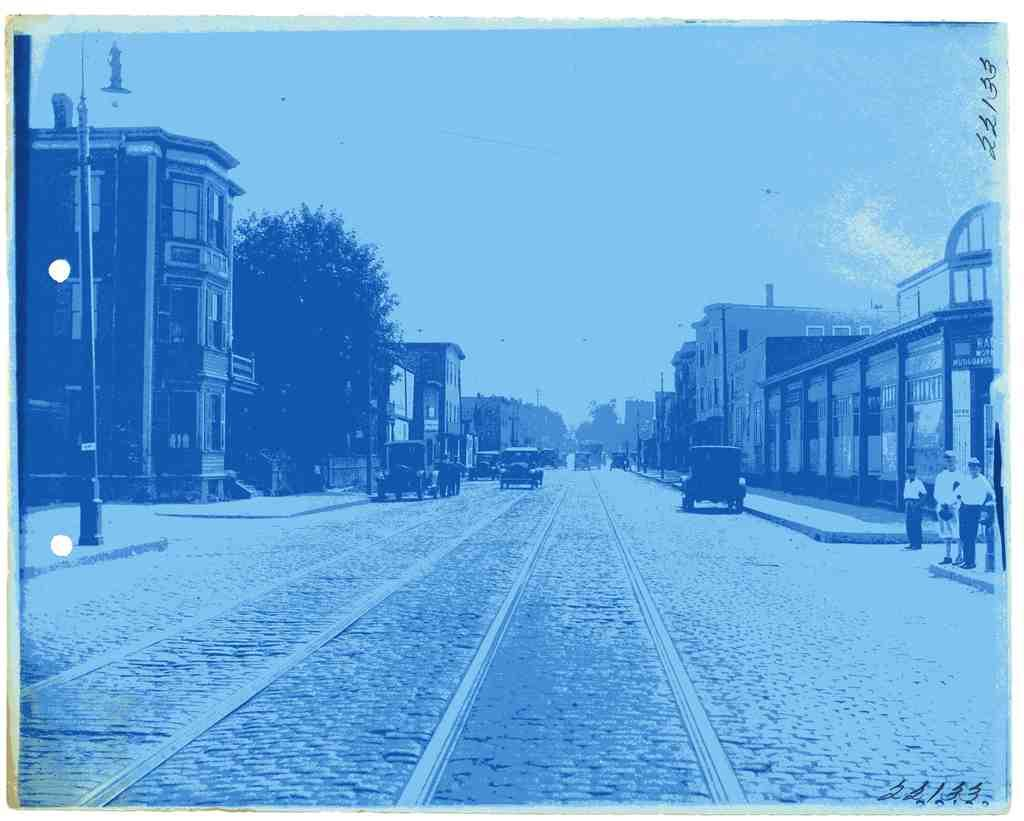What can be seen on the road in the image? There are vehicles on the road in the image. What else is present in the image besides the vehicles? There are people standing in the image. What is visible in the background of the image? The sky, trees, buildings, poles, and banners are visible in the background of the image. Can you describe the zephyr that is blowing the robin's feathers in the image? There is no zephyr or robin present in the image. What type of system is being used to control the vehicles in the image? The image does not provide information about a system controlling the vehicles; it only shows vehicles on the road and people standing nearby. 